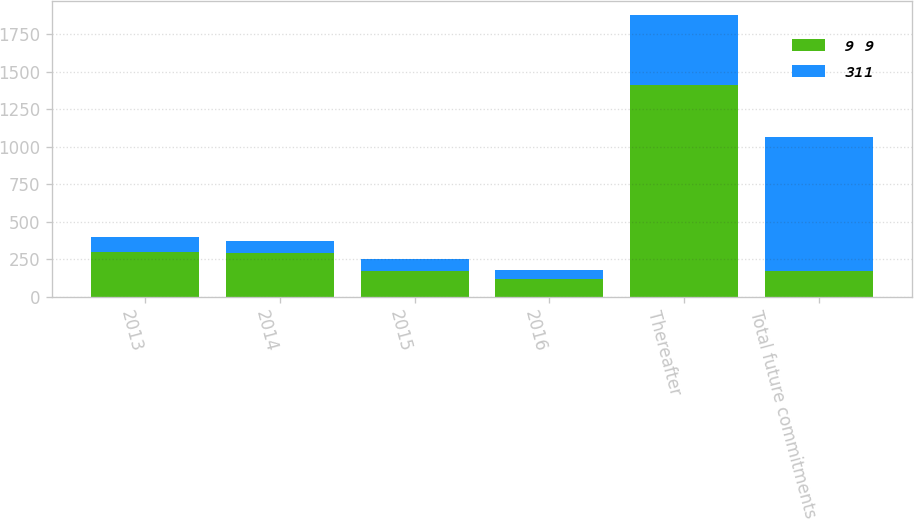<chart> <loc_0><loc_0><loc_500><loc_500><stacked_bar_chart><ecel><fcel>2013<fcel>2014<fcel>2015<fcel>2016<fcel>Thereafter<fcel>Total future commitments<nl><fcel>9 9<fcel>300<fcel>289<fcel>174<fcel>115<fcel>1412<fcel>174<nl><fcel>311<fcel>100<fcel>83<fcel>75<fcel>65<fcel>469<fcel>891<nl></chart> 